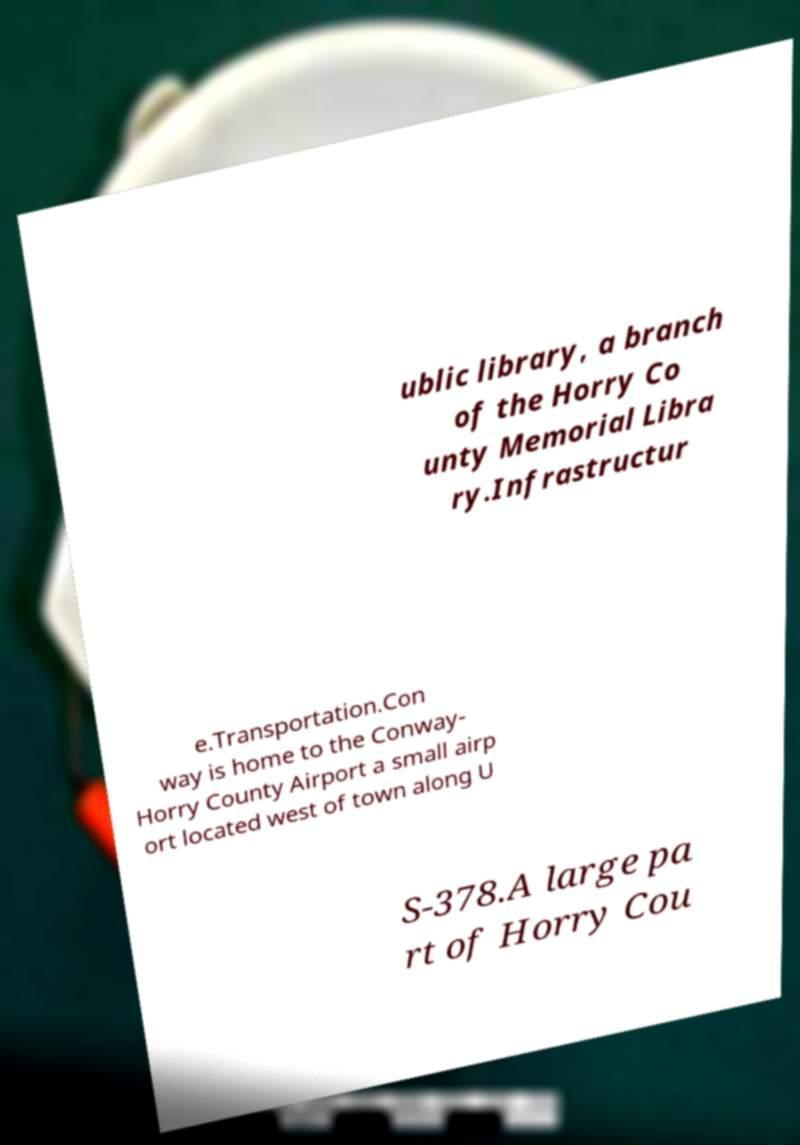Can you accurately transcribe the text from the provided image for me? ublic library, a branch of the Horry Co unty Memorial Libra ry.Infrastructur e.Transportation.Con way is home to the Conway- Horry County Airport a small airp ort located west of town along U S-378.A large pa rt of Horry Cou 